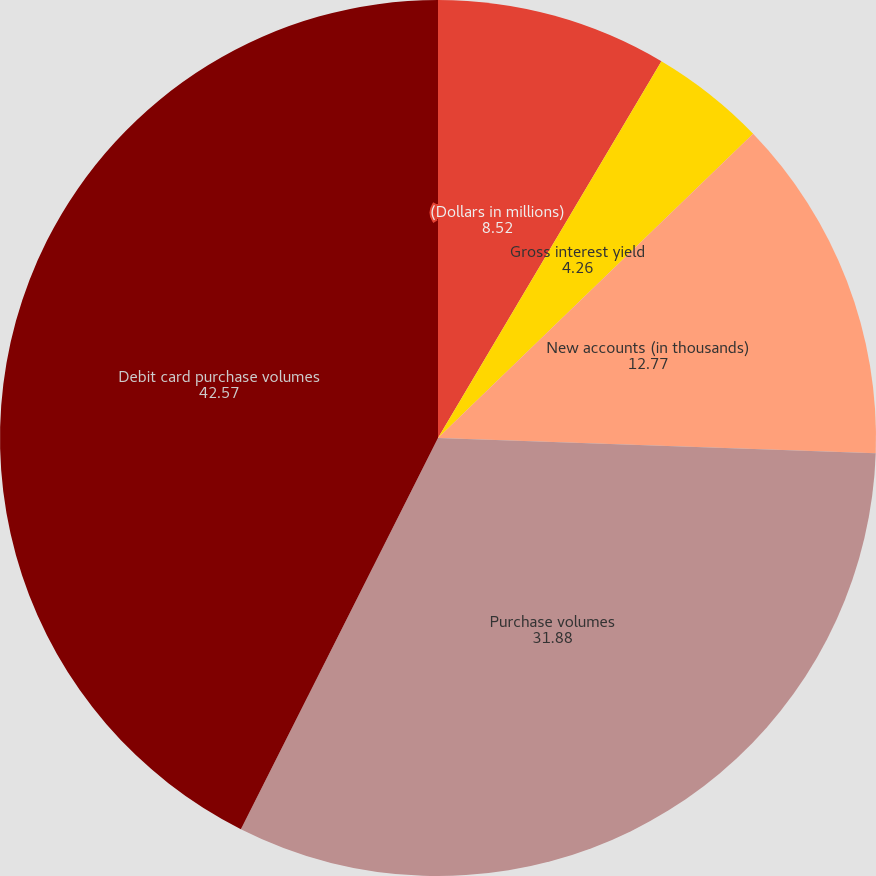Convert chart to OTSL. <chart><loc_0><loc_0><loc_500><loc_500><pie_chart><fcel>(Dollars in millions)<fcel>Gross interest yield<fcel>Risk-adjusted margin<fcel>New accounts (in thousands)<fcel>Purchase volumes<fcel>Debit card purchase volumes<nl><fcel>8.52%<fcel>4.26%<fcel>0.0%<fcel>12.77%<fcel>31.88%<fcel>42.57%<nl></chart> 